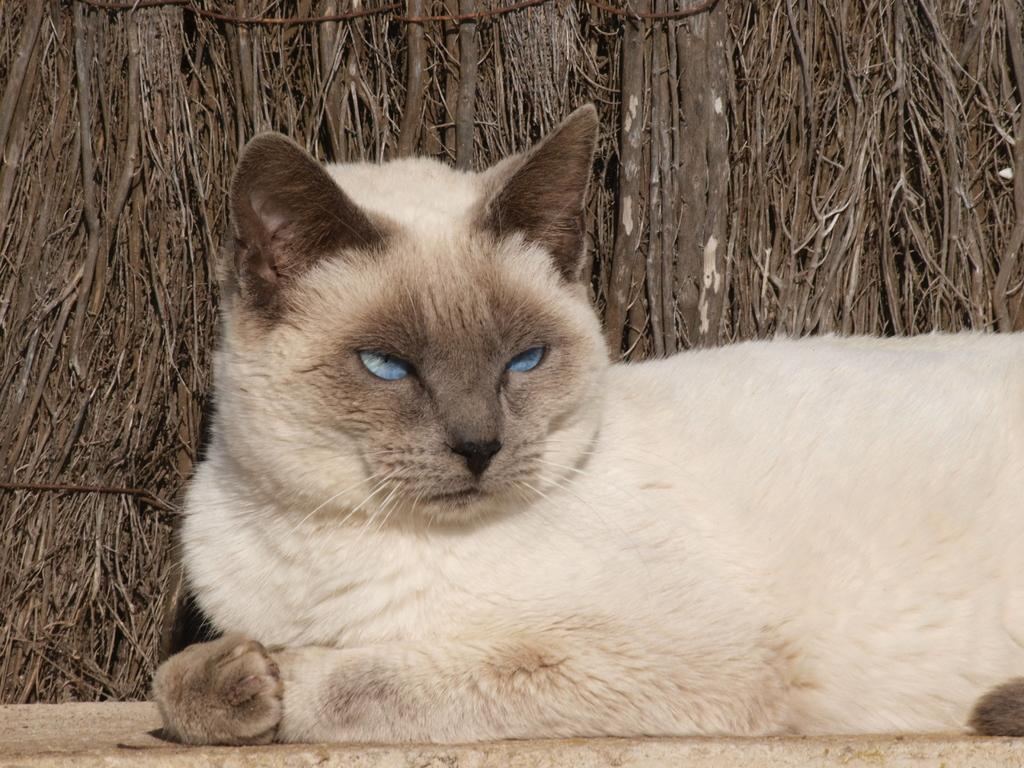What is the main subject of the image? There is a cat in the center of the image. What can be seen in the background of the image? There are twigs in the background of the image. What type of music is the band playing in the background of the image? There is no band present in the image, so it is not possible to determine what type of music they might be playing. 